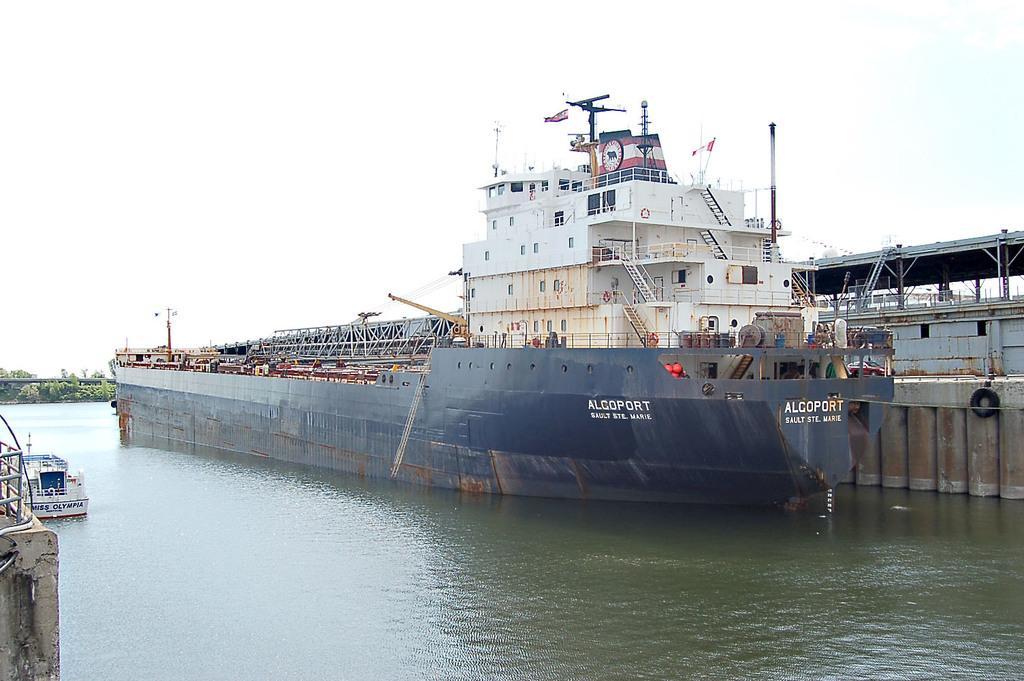Describe this image in one or two sentences. In this image we can see there are ships on the water. And there are trees, pole, fence and a wall. At the top there is a sky. 